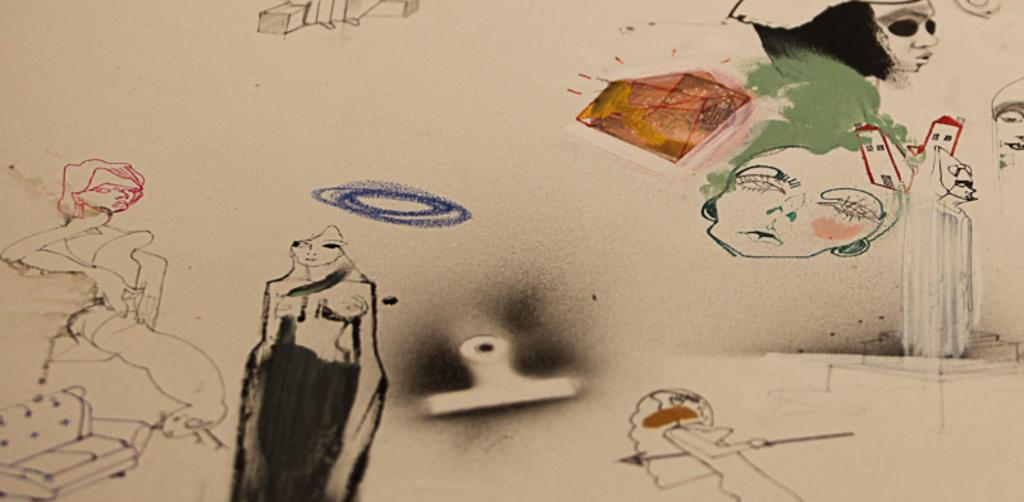What is depicted in the image? There is a drawing of people in the image. Can you describe the people in the drawing? Unfortunately, the facts provided do not give any details about the people in the drawing. What medium is used for the drawing? The facts do not specify the medium used for the drawing. What type of juice is being served on the farm in the image? There is no mention of juice or a farm in the image; it only contains a drawing of people. 